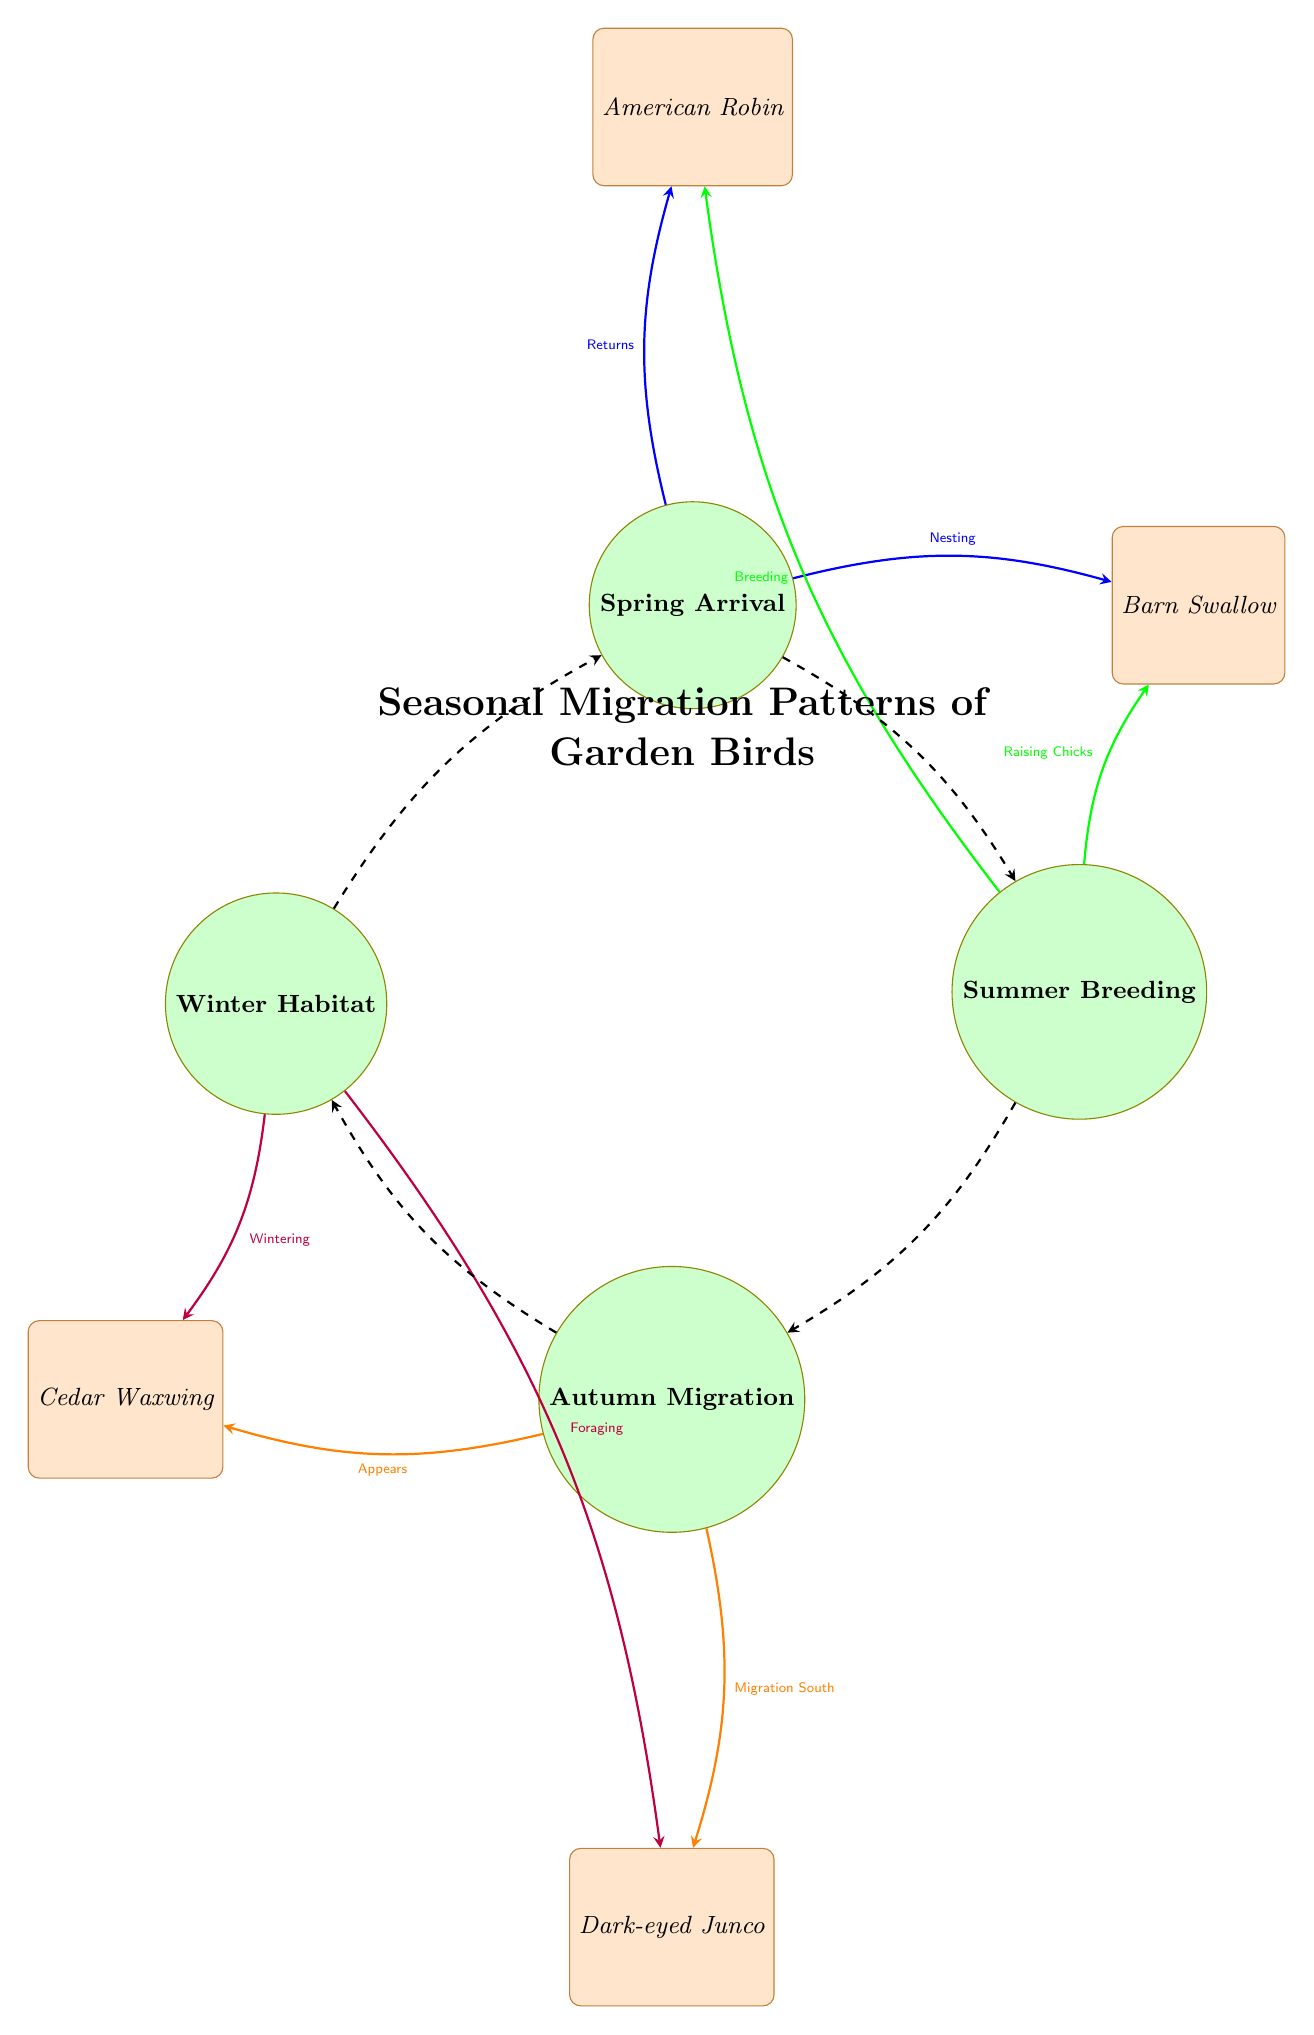What is the title of the diagram? The title is provided at the top of the diagram and summarizes the content it represents, which is "Seasonal Migration Patterns of Garden Birds."
Answer: Seasonal Migration Patterns of Garden Birds How many bird species are represented in the diagram? The diagram shows four different bird species: American Robin, Barn Swallow, Cedar Waxwing, and Dark-eyed Junco. By counting these species, we find that there are four.
Answer: 4 What is the relationship between Spring Arrival and Barn Swallow? The diagram indicates that Spring Arrival is connected to Barn Swallow with the label "Nesting." This shows that during the spring, Barn Swallows begin to nest.
Answer: Nesting Which bird appears during Autumn Migration? The diagram lists Cedar Waxwing as the bird that appears during Autumn Migration, according to the connection drawn with the label "Appears."
Answer: Cedar Waxwing What action takes place in Summer Breeding related to American Robin? The action related to American Robin during Summer Breeding is labeled "Breeding" in the diagram. This indicates that this species breeds in the summer season.
Answer: Breeding What season does Dark-eyed Junco migrate south? The diagram specifies that Dark-eyed Junco is associated with the action of "Migration South" during the Autumn Migration phase, indicating the time it heads south.
Answer: Autumn Migration Which bird is involved in Winter Habitat activities? The diagram shows that Cedar Waxwing is involved in "Wintering" activities during the Winter Habitat season, as indicated by the connection leading to this bird.
Answer: Cedar Waxwing What season directly follows Summer Breeding? The diagram uses dashed arrows to indicate seasonal transitions. The season that directly follows Summer Breeding is Autumn Migration.
Answer: Autumn Migration During which season do you see Raising Chicks? According to the diagram, "Raising Chicks" occurs during Summer Breeding, showing the specific activity taking place in that season.
Answer: Summer Breeding 